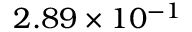Convert formula to latex. <formula><loc_0><loc_0><loc_500><loc_500>2 . 8 9 \times 1 0 ^ { - 1 }</formula> 